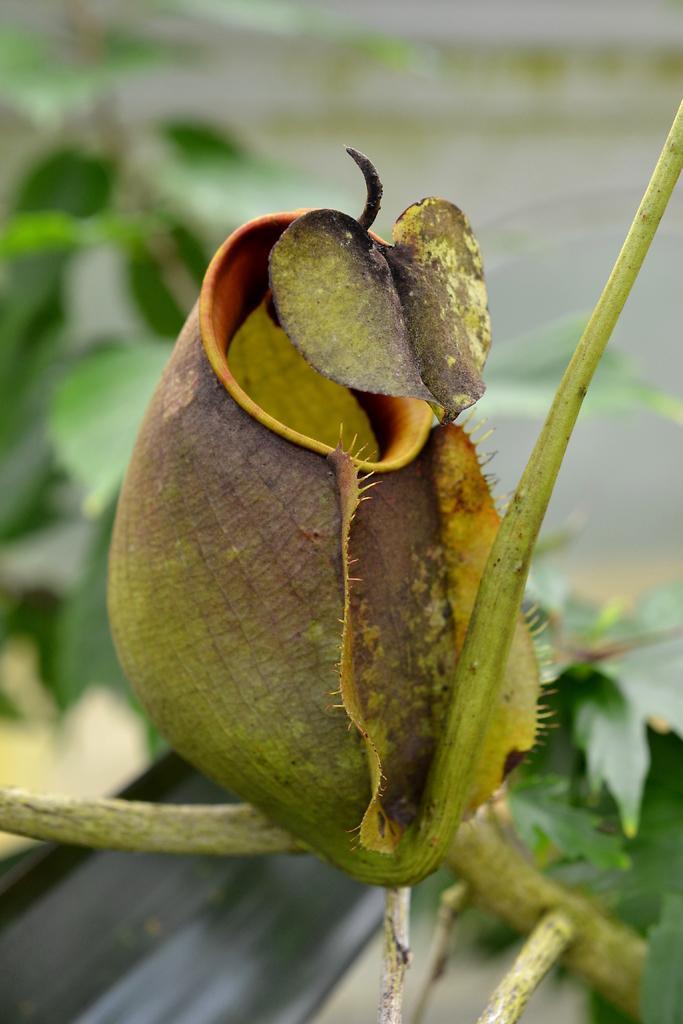In one or two sentences, can you explain what this image depicts? In this image, this looks like a flower bud, which is to the stem. I think these are the leaves. The background looks blurry. 